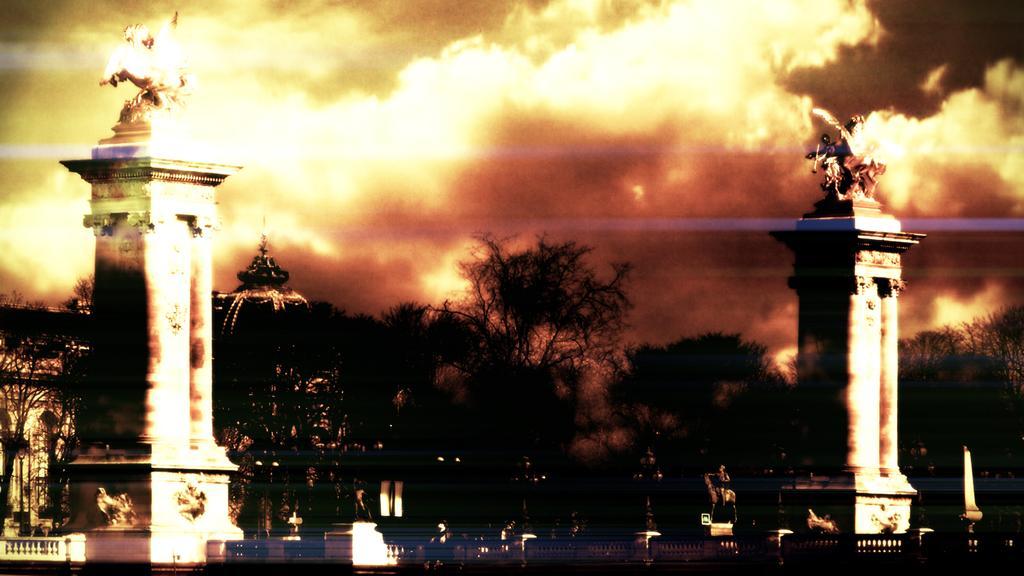Please provide a concise description of this image. This looks like an edited image. I can see the sculptures, which are the top of the pillars. I can see the trees. This looks like a building. These are the clouds in the sky. At the bottom of the image, I think these are the iron grilles. 